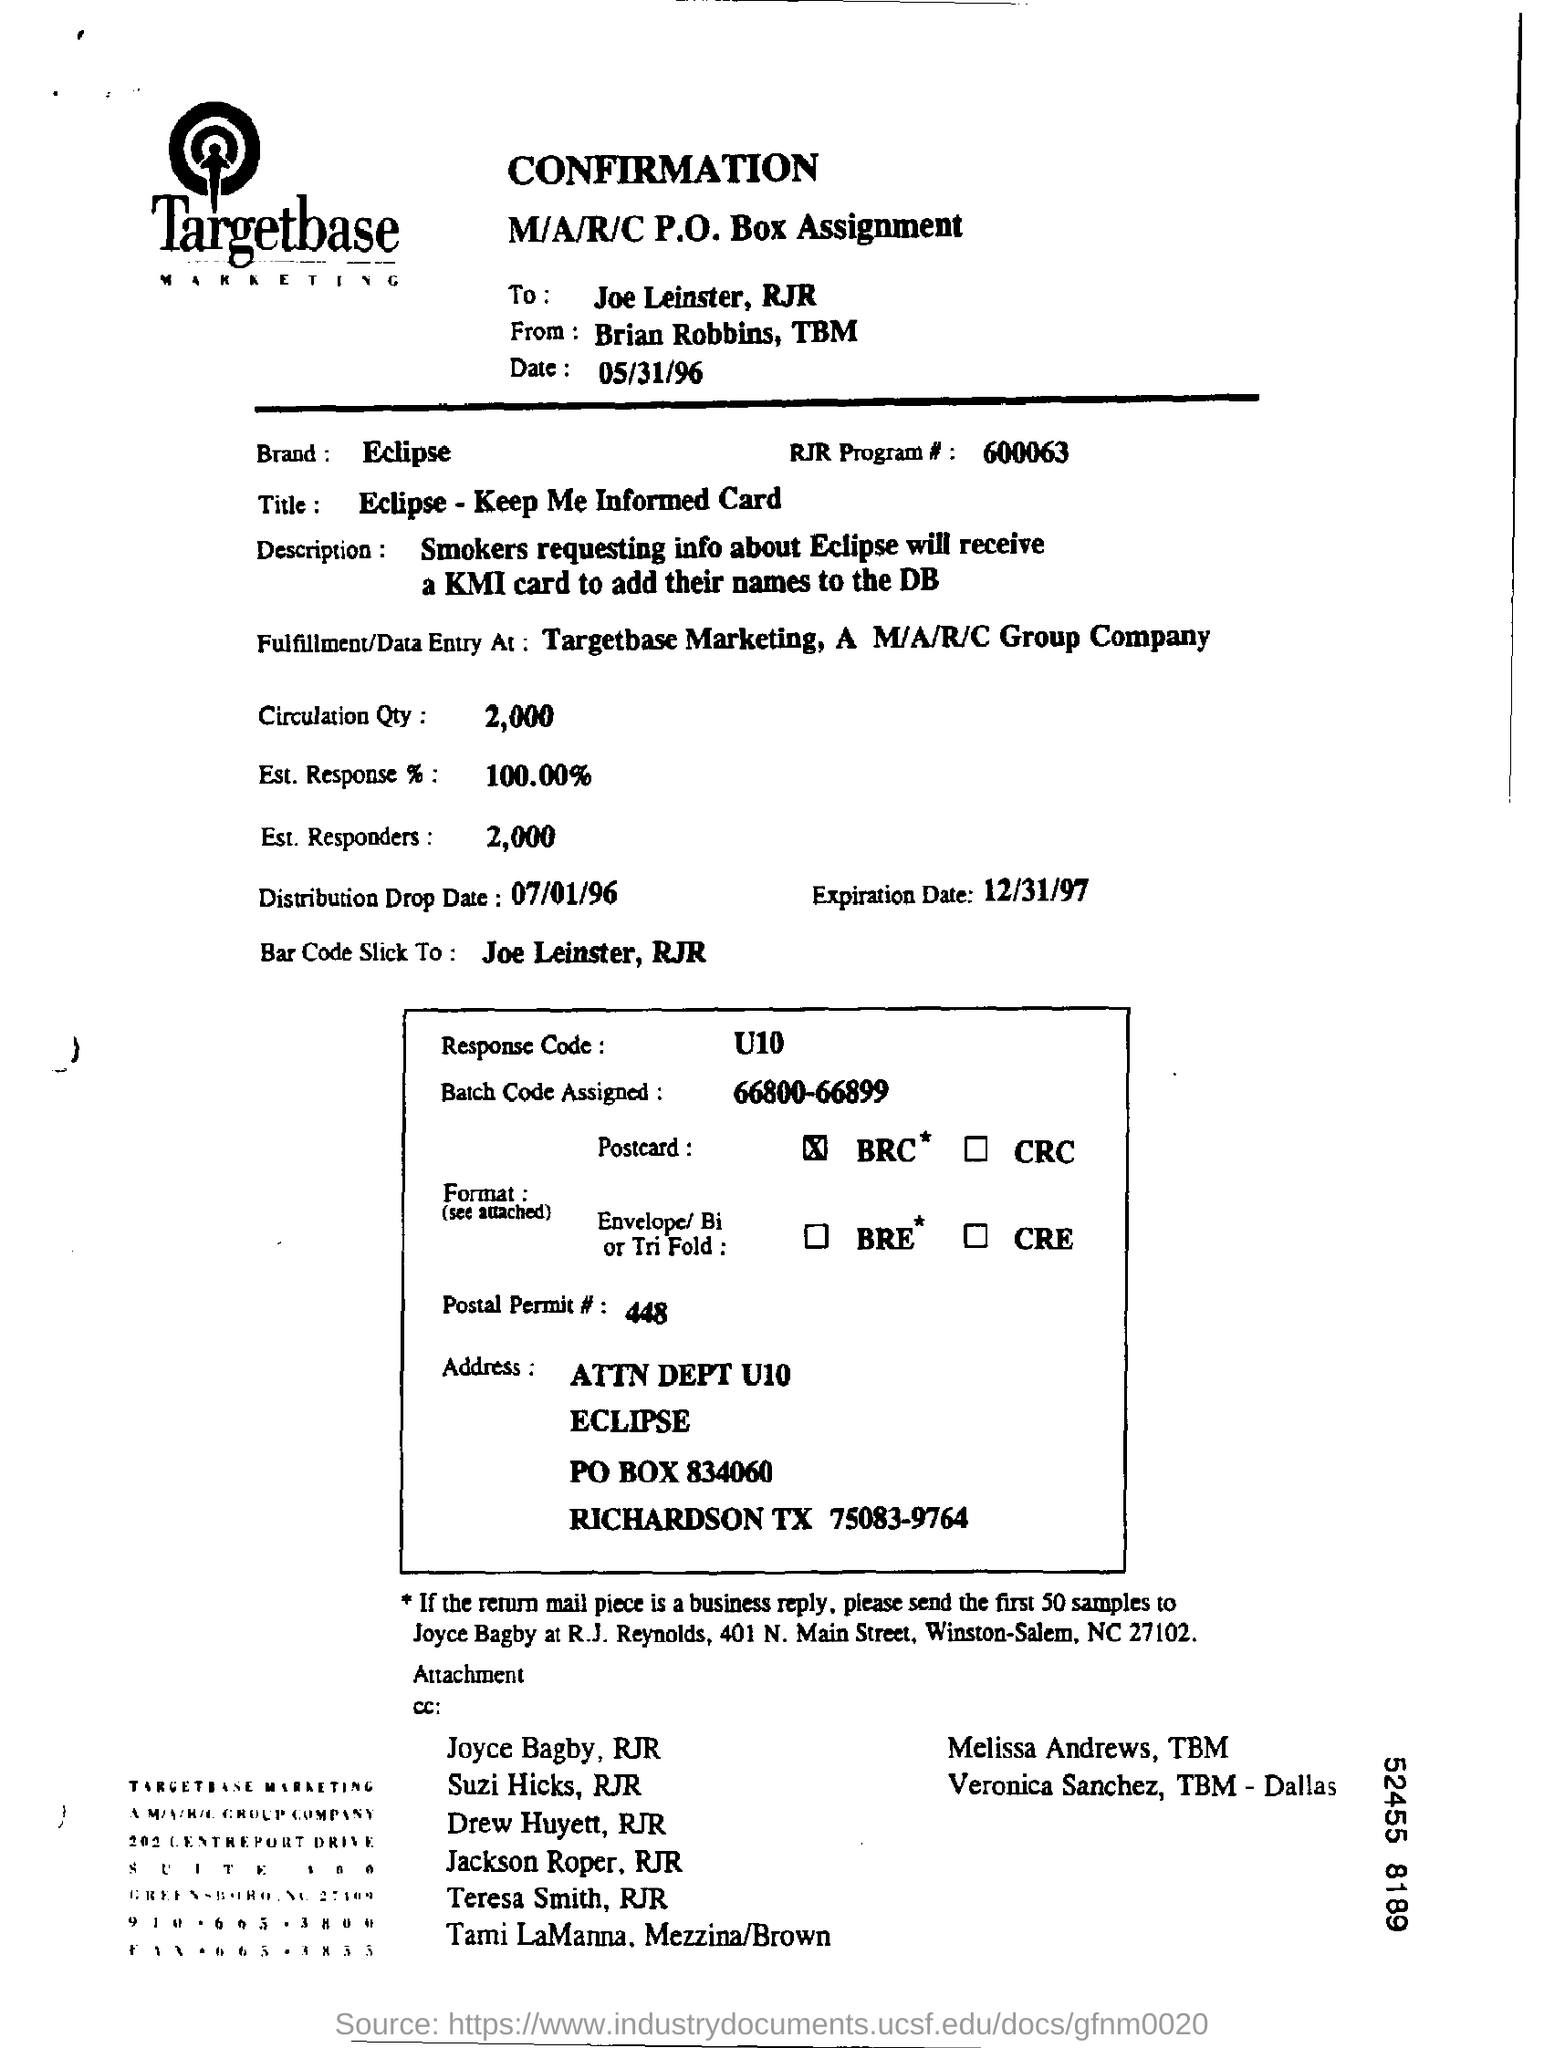What is the Brand name ?
Keep it short and to the point. Eclipse. Which Batch code is assigned ?
Offer a terse response. 66800-66899. What is the Circulation Quantity ?
Your answer should be compact. 2,000. To which the Bar code is stick ?
Provide a succinct answer. Joe leinster , rjr. 